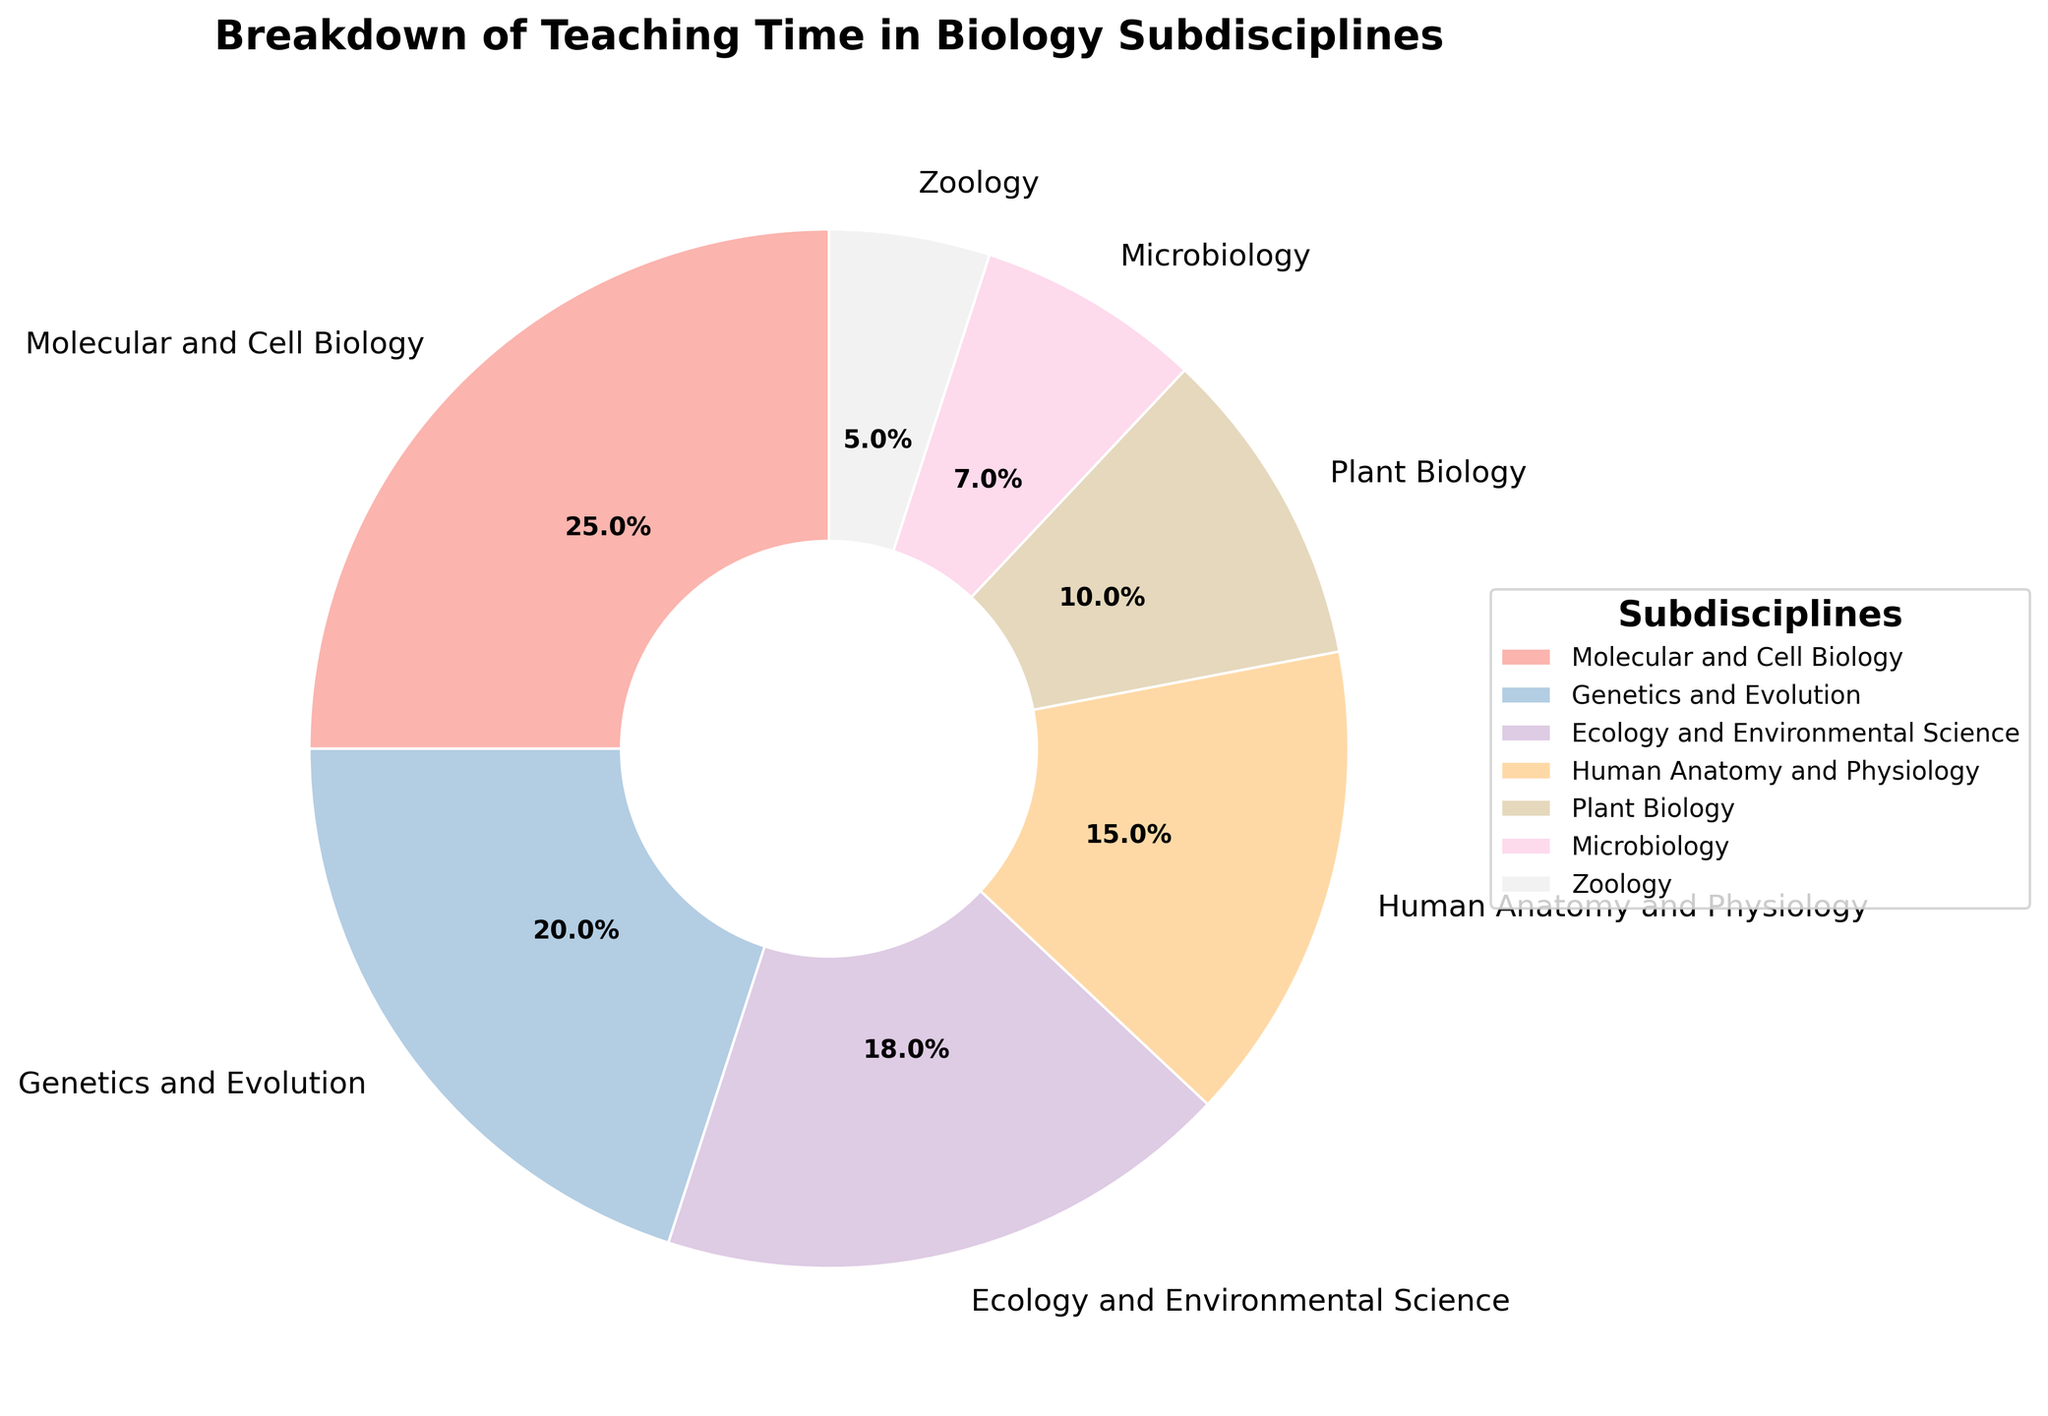what percentage of teaching time is allocated to Genetics and Evolution? Locate the segment labeled "Genetics and Evolution" in the pie chart, and read the percentage value displayed there.
Answer: 20% which subdiscipline has the smallest allocation in teaching time? Identify the segment with the smallest area in the pie chart and read the label.
Answer: Zoology what is the combined teaching time allocation for Molecular and Cell Biology and Human Anatomy and Physiology? Find the percentage values for "Molecular and Cell Biology" (25%) and "Human Anatomy and Physiology" (15%), then sum them up: 25% + 15% = 40%
Answer: 40% is the teaching time spent on Microbiology more or less than that spent on Plant Biology? Compare the percentages of "Microbiology" (7%) and "Plant Biology" (10%) as shown on the pie chart.
Answer: Less which two subdisciplines together make up more than one-third of the total teaching time? Determine the two subdisciplines whose combined percentage exceeds 33.3%. "Molecular and Cell Biology" (25%) and "Genetics and Evolution" (20%) sum to 45%, which is more than one-third.
Answer: Molecular and Cell Biology and Genetics and Evolution how does the teaching time allocated to Ecology and Environmental Science compare to that of Human Anatomy and Physiology? Compare the percentage values for "Ecology and Environmental Science" (18%) and "Human Anatomy and Physiology" (15%). 18% is greater than 15%.
Answer: Greater what visual attribute distinguishes Molecular and Cell Biology's segment in the pie chart? Notice the start angle and size of the portion of the pie chart allocated to "Molecular and Cell Biology," which is the largest segment.
Answer: Largest segment if you sum the teaching time for Microbiology, Plant Biology, and Zoology, what percentage do you get? Add the percentages for "Microbiology" (7%), "Plant Biology" (10%), and "Zoology" (5%): 7% + 10% + 5% = 22%
Answer: 22% what is the second most allocated subdiscipline in terms of teaching time? Look at the segment with the second-largest portion of the pie chart, which is labeled "Genetics and Evolution" with 20%.
Answer: Genetics and Evolution 